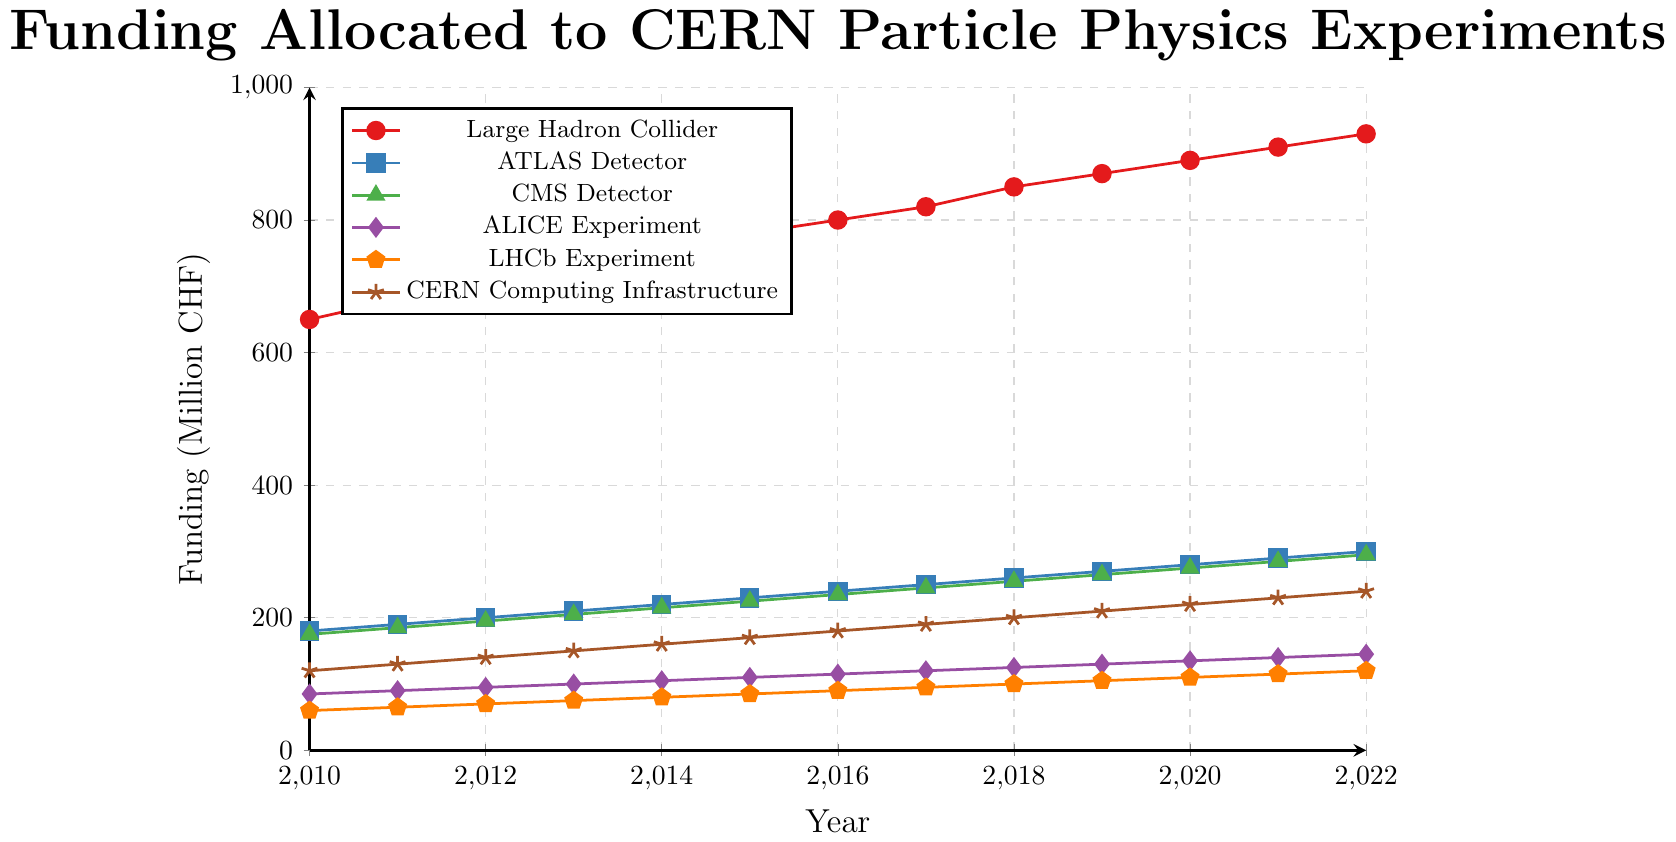What was the total funding allocated to the Large Hadron Collider (LHC) over the years 2010 to 2022? Sum up the yearly funding amounts for the Large Hadron Collider from 2010 to 2022: 650 + 680 + 700 + 720 + 750 + 780 + 800 + 820 + 850 + 870 + 890 + 910 + 930. Total = 10350 million CHF
Answer: 10350 million CHF In 2022, which project received the least amount of funding? Look at the funding levels for all projects for the year 2022 and identify the smallest value. The values are: LHC (930), ATLAS (300), CMS (295), ALICE (145), LHCb (120), CERN Computing (240). The smallest value is for LHCb Experiment.
Answer: LHCb Experiment How much more funding was allocated to the CERN Computing Infrastructure in 2021 compared to 2010? Subtract the 2010 funding for CERN Computing Infrastructure from the 2021 funding: 230 (2021) - 120 (2010) = 110. Difference = 110 million CHF
Answer: 110 million CHF Which year saw the highest increase in funding for any single project compared to the previous year? Calculate the year-to-year funding increase for each project and identify the maximum increase. For the LHC: (680-650 = 30), (700-680 = 20), ... ; repeat for other projects and observe the largest increase is for LHC from 2017 to 2018 (850 - 820 = 30).
Answer: 2018 On average, how much funding was allocated to the ATLAS Detector per year from 2010 to 2022? Sum the yearly funding for ATLAS from 2010 to 2022 and divide by the number of years: (180 + 190 + 200 + 210 + 220 + 230 + 240 + 250 + 260 + 270 + 280 + 290 + 300) / 13 ≈ 230. Average = 230 million CHF per year
Answer: 230 million CHF Which project had the least variability in its yearly funding from 2010 to 2022? Calculate the range of funding for each project (max - min) over the years from 2010 to 2022. The ranges are: LHC (930-650=280), ATLAS (300-180=120), CMS (295-175=120), ALICE (145-85=60), LHCb (120-60=60), CERN Computing (240-120=120). The smallest range is for ALICE and LHCb (both 60).
Answer: ALICE Experiment and LHCb Experiment By how much did the funding for the ALICE Experiment increase from 2010 to 2022? Subtract the 2010 funding amount for ALICE Experiment from the 2022 amount: 145 (2022) - 85 (2010) = 60. Increase = 60 million CHF
Answer: 60 million CHF Between 2015 and 2020, which year had the highest funding allocated to the CMS Detector? Look at the funding amounts for the CMS Detector between 2015 and 2020: 225 (2015), 235 (2016), 245 (2017), 255 (2018), 265 (2019), 275 (2020). Identify the highest: 275 in 2020.
Answer: 2020 Visual question: Which project is represented by the line with diamond markers? Observe the visual attributes (diamond markers) and identify the project: ALICE Experiment
Answer: ALICE Experiment 